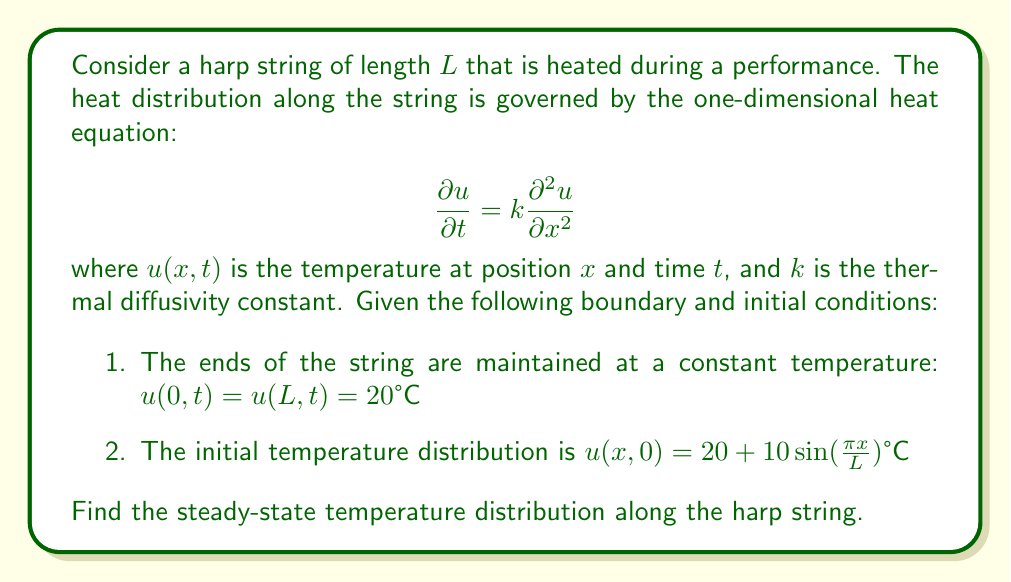Provide a solution to this math problem. To solve this problem, we need to follow these steps:

1) First, we recognize that the steady-state solution is independent of time. This means $\frac{\partial u}{\partial t} = 0$. 

2) The heat equation then reduces to:

   $$0 = k\frac{\partial^2 u}{\partial x^2}$$

3) This simplifies to:

   $$\frac{\partial^2 u}{\partial x^2} = 0$$

4) The general solution to this equation is:

   $$u(x) = Ax + B$$

   where $A$ and $B$ are constants we need to determine.

5) We can use the boundary conditions to find these constants:

   At $x = 0$: $u(0) = B = 20$
   At $x = L$: $u(L) = AL + 20 = 20$

6) From the second condition, we can deduce that $A = 0$.

7) Therefore, the steady-state solution is:

   $$u(x) = 20$$

This means that regardless of the initial temperature distribution, the steady-state temperature will be uniform along the string at 20°C.
Answer: $u(x) = 20°C$ 